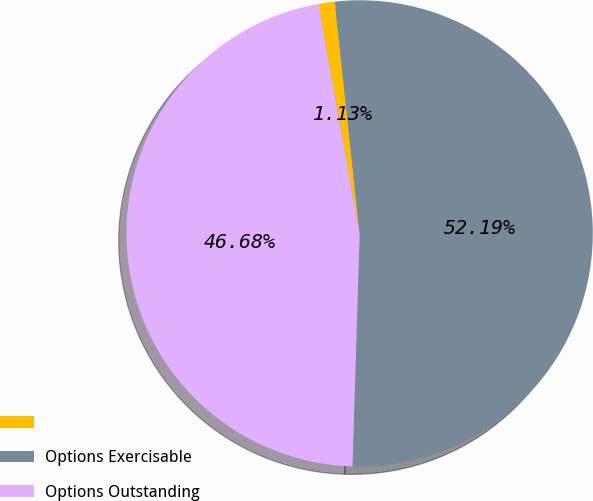Convert chart. <chart><loc_0><loc_0><loc_500><loc_500><pie_chart><ecel><fcel>Options Exercisable<fcel>Options Outstanding<nl><fcel>1.13%<fcel>52.19%<fcel>46.68%<nl></chart> 